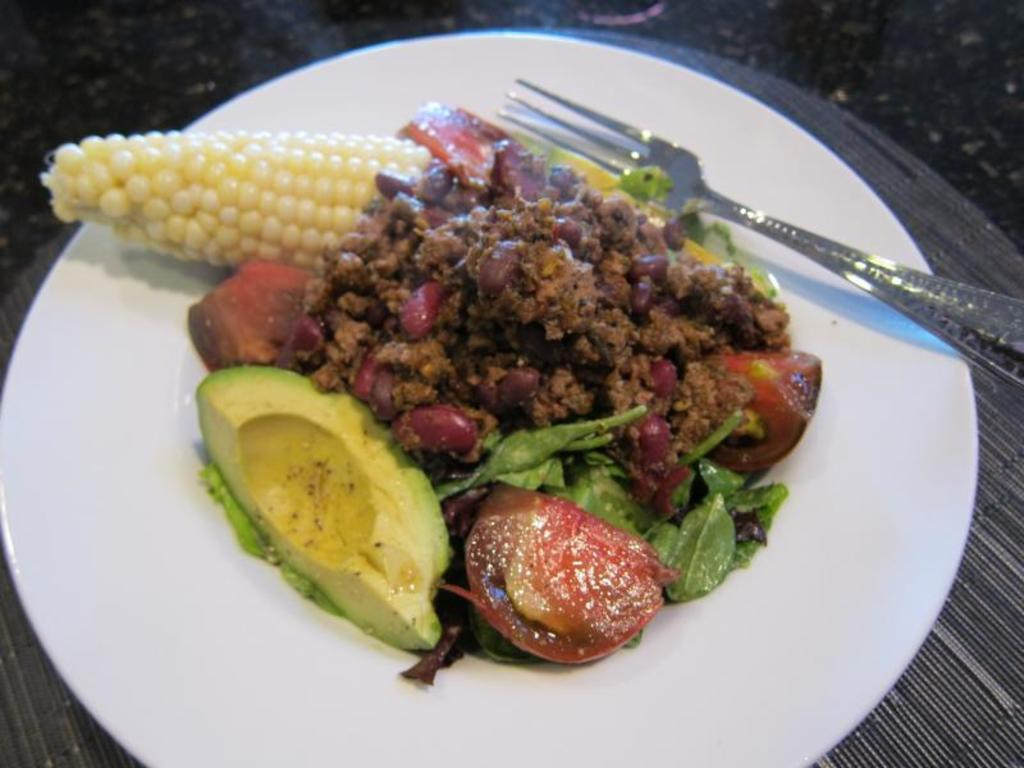What is the main food item visible in the image? There is a food item served in a plate. Can you describe the surface on which the plate is placed? The plate is placed on a wooden table. How many cars are parked on the wooden table in the image? There are no cars present in the image; it features a food item served in a plate on a wooden table. 